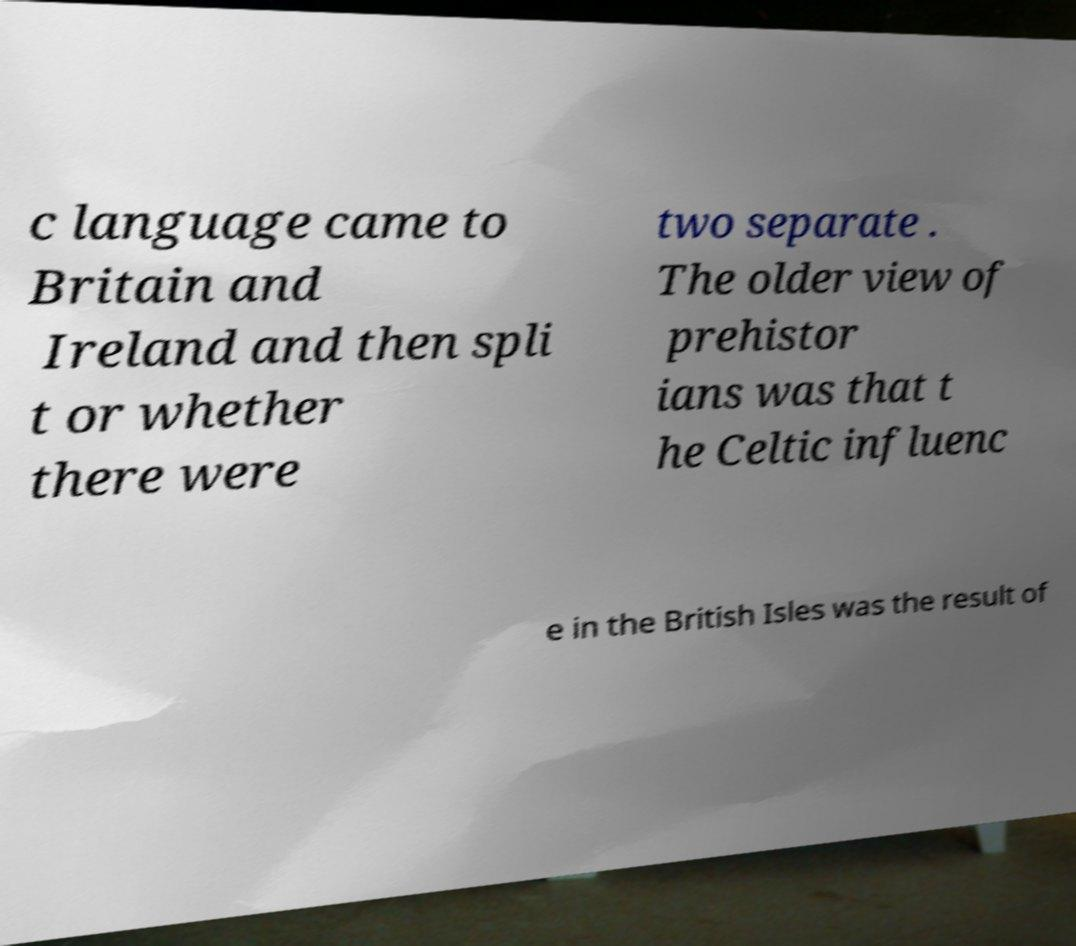Please read and relay the text visible in this image. What does it say? c language came to Britain and Ireland and then spli t or whether there were two separate . The older view of prehistor ians was that t he Celtic influenc e in the British Isles was the result of 